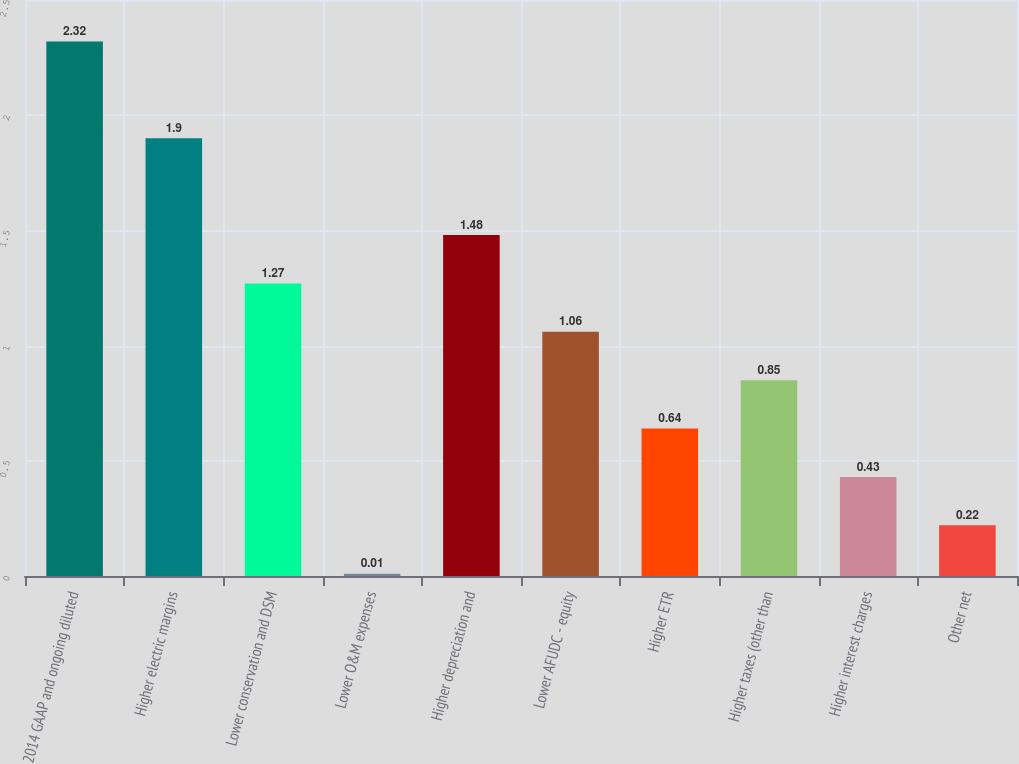Convert chart. <chart><loc_0><loc_0><loc_500><loc_500><bar_chart><fcel>2014 GAAP and ongoing diluted<fcel>Higher electric margins<fcel>Lower conservation and DSM<fcel>Lower O&M expenses<fcel>Higher depreciation and<fcel>Lower AFUDC - equity<fcel>Higher ETR<fcel>Higher taxes (other than<fcel>Higher interest charges<fcel>Other net<nl><fcel>2.32<fcel>1.9<fcel>1.27<fcel>0.01<fcel>1.48<fcel>1.06<fcel>0.64<fcel>0.85<fcel>0.43<fcel>0.22<nl></chart> 